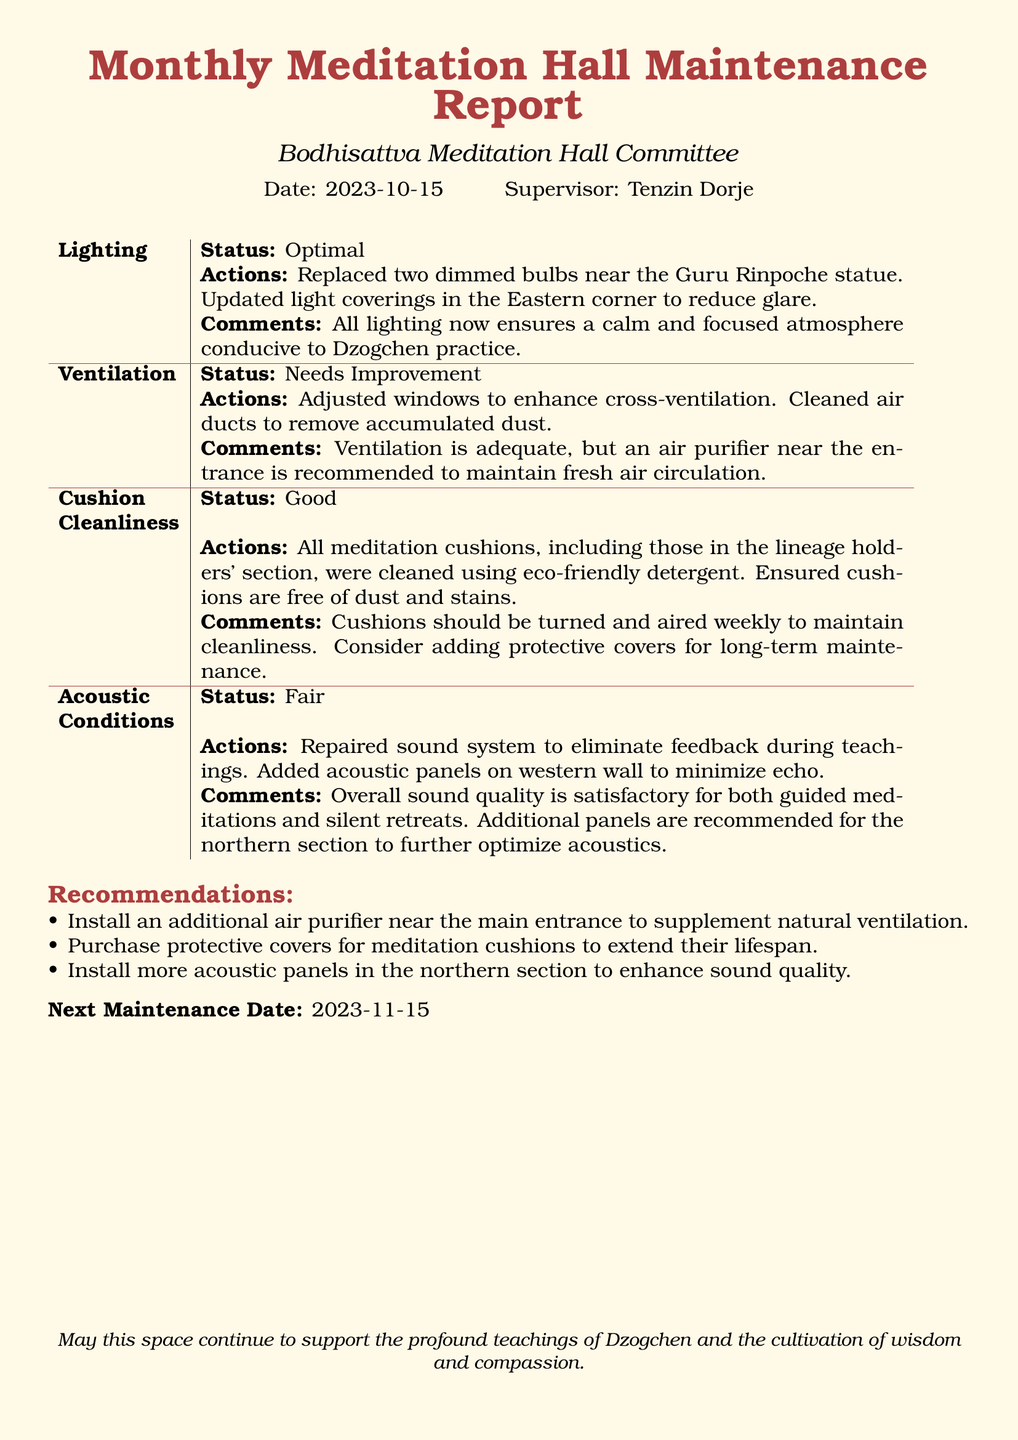What is the date of the report? The date of the report is specified at the beginning, which is 2023-10-15.
Answer: 2023-10-15 Who is the supervisor? The supervisor's name is listed as Tenzin Dorje in the report.
Answer: Tenzin Dorje What is the status of lighting? The lighting status is mentioned in the report, indicating it is optimal.
Answer: Optimal What actions were taken for ventilation? The report outlines the actions taken to improve ventilation, which included adjusting windows and cleaning air ducts.
Answer: Adjusted windows, cleaned air ducts What recommendations are made for acoustic conditions? The recommendations focus on enhancements to improve sound quality, particularly in the northern section.
Answer: Install more acoustic panels How often should cushions be turned and aired? The report suggests that cushions should be turned and aired weekly.
Answer: Weekly What is stated about the cleanliness of the cushions? The report states that all meditation cushions were cleaned and are free of dust and stains.
Answer: Good What is the next maintenance date? The next maintenance date is noted at the end of the report, specifically mentioned as 2023-11-15.
Answer: 2023-11-15 What were the main actions taken regarding lighting? The actions taken for lighting involved replacing dimmed bulbs and updating light coverings.
Answer: Replaced dimmed bulbs, updated light coverings 